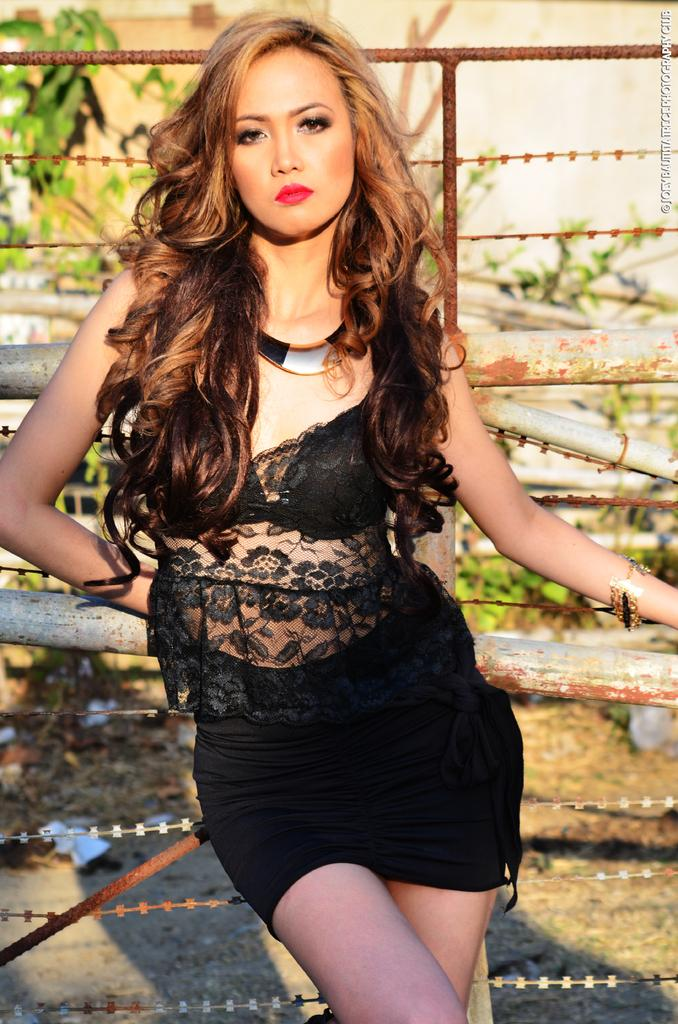What is the main subject of the image? There is a woman in the image. What is the woman doing in the image? The woman is watching and standing in the image. What can be seen in the background of the image? There are poles, rods, plants, a wire fence, and the ground visible in the background of the image. What type of jewel is the woman offering in the image? There is no jewel present in the image, nor is the woman offering anything. 